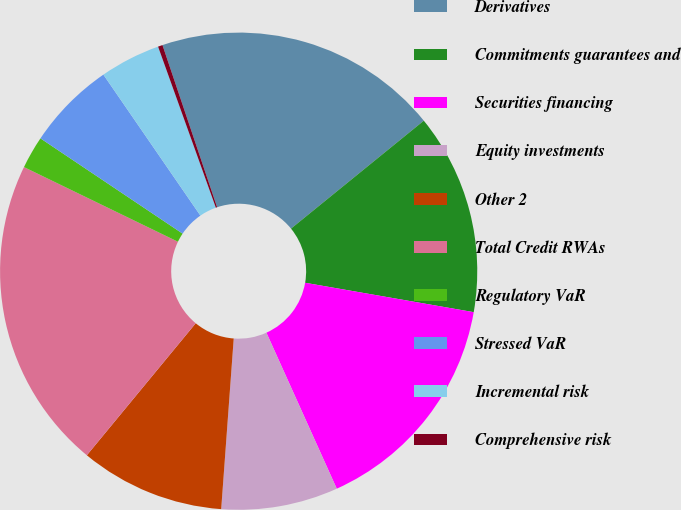Convert chart. <chart><loc_0><loc_0><loc_500><loc_500><pie_chart><fcel>Derivatives<fcel>Commitments guarantees and<fcel>Securities financing<fcel>Equity investments<fcel>Other 2<fcel>Total Credit RWAs<fcel>Regulatory VaR<fcel>Stressed VaR<fcel>Incremental risk<fcel>Comprehensive risk<nl><fcel>19.31%<fcel>13.61%<fcel>15.51%<fcel>7.91%<fcel>9.81%<fcel>21.21%<fcel>2.21%<fcel>6.01%<fcel>4.11%<fcel>0.31%<nl></chart> 